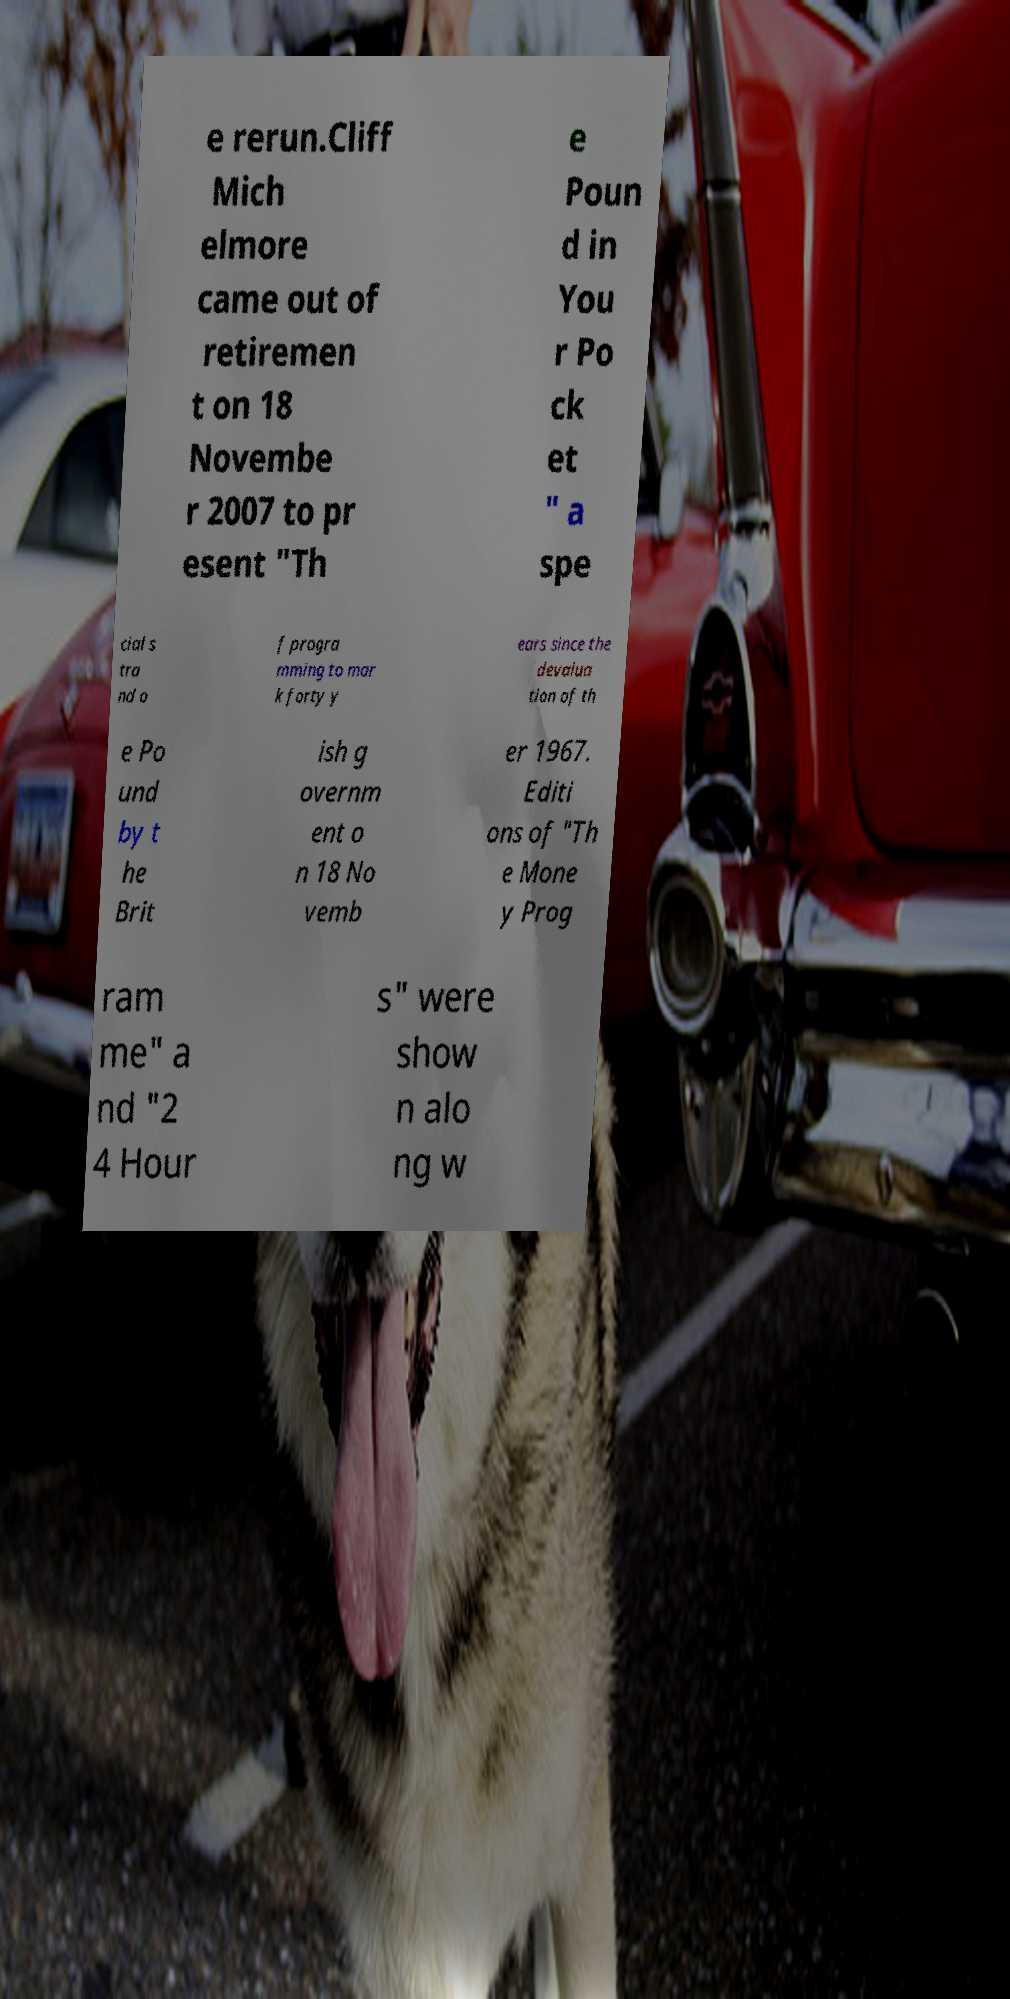Can you accurately transcribe the text from the provided image for me? e rerun.Cliff Mich elmore came out of retiremen t on 18 Novembe r 2007 to pr esent "Th e Poun d in You r Po ck et " a spe cial s tra nd o f progra mming to mar k forty y ears since the devalua tion of th e Po und by t he Brit ish g overnm ent o n 18 No vemb er 1967. Editi ons of "Th e Mone y Prog ram me" a nd "2 4 Hour s" were show n alo ng w 